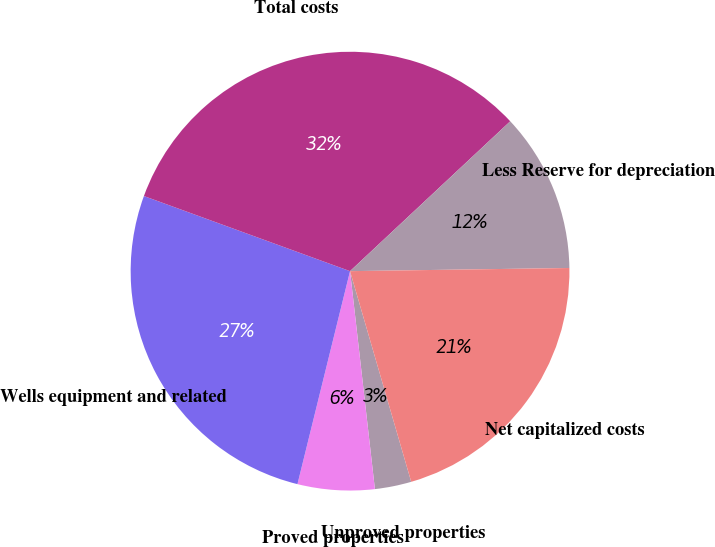<chart> <loc_0><loc_0><loc_500><loc_500><pie_chart><fcel>Unproved properties<fcel>Proved properties<fcel>Wells equipment and related<fcel>Total costs<fcel>Less Reserve for depreciation<fcel>Net capitalized costs<nl><fcel>2.69%<fcel>5.66%<fcel>26.71%<fcel>32.47%<fcel>11.74%<fcel>20.73%<nl></chart> 